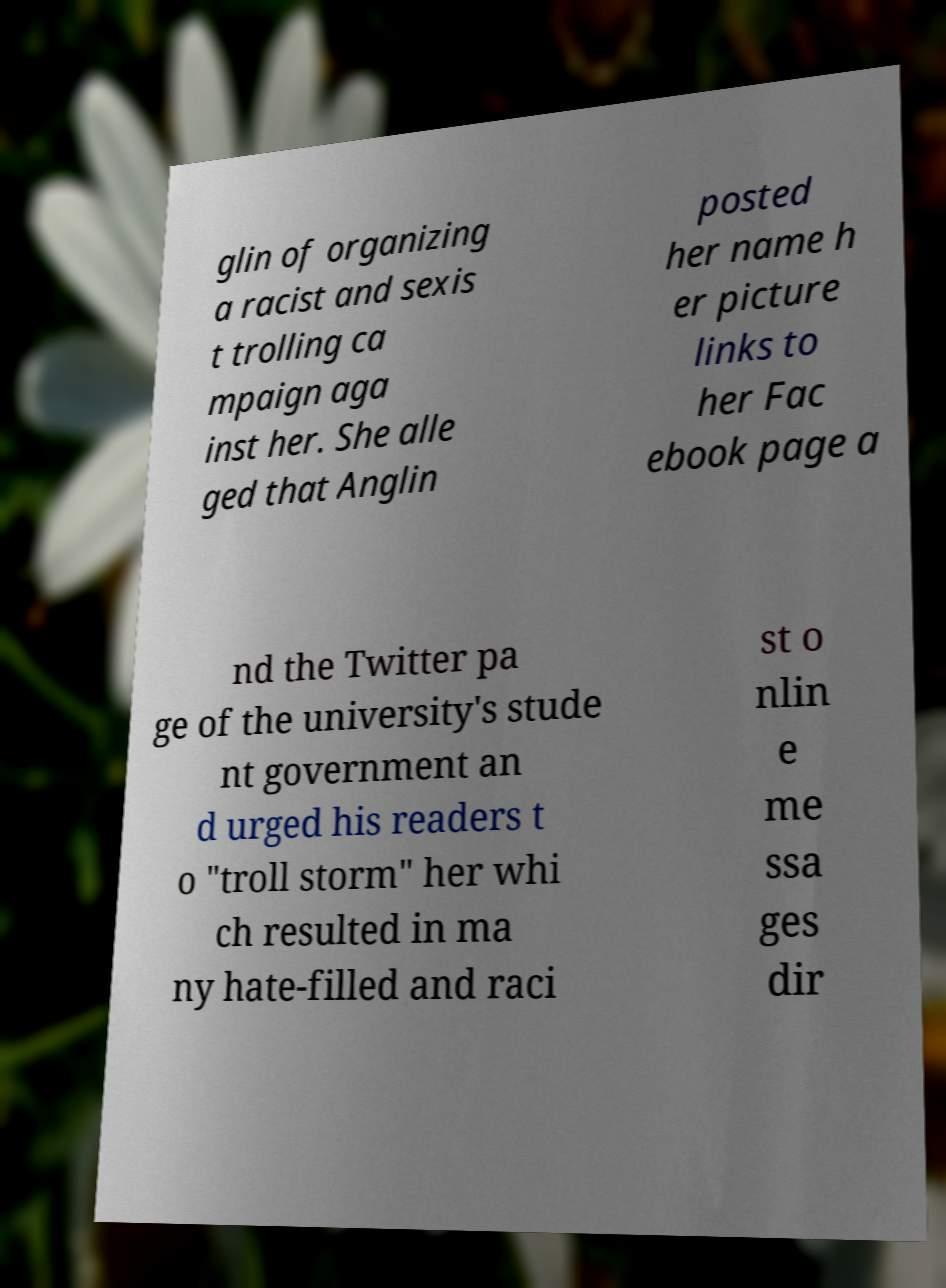There's text embedded in this image that I need extracted. Can you transcribe it verbatim? glin of organizing a racist and sexis t trolling ca mpaign aga inst her. She alle ged that Anglin posted her name h er picture links to her Fac ebook page a nd the Twitter pa ge of the university's stude nt government an d urged his readers t o "troll storm" her whi ch resulted in ma ny hate-filled and raci st o nlin e me ssa ges dir 